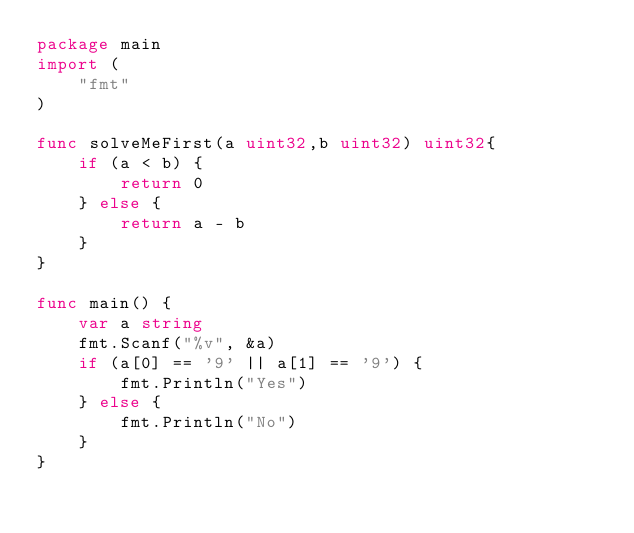<code> <loc_0><loc_0><loc_500><loc_500><_Go_>package main
import (
    "fmt"
)

func solveMeFirst(a uint32,b uint32) uint32{
    if (a < b) {
        return 0
    } else {
        return a - b
    }
}

func main() {
    var a string
    fmt.Scanf("%v", &a)
    if (a[0] == '9' || a[1] == '9') {
        fmt.Println("Yes")
    } else {
        fmt.Println("No")
    }
}

</code> 